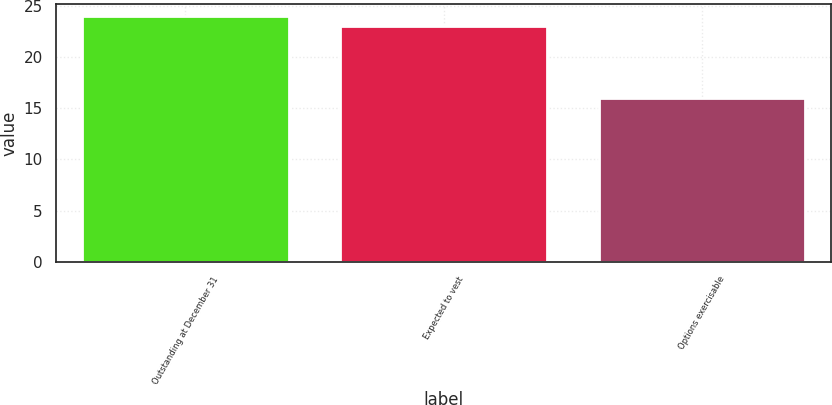Convert chart. <chart><loc_0><loc_0><loc_500><loc_500><bar_chart><fcel>Outstanding at December 31<fcel>Expected to vest<fcel>Options exercisable<nl><fcel>24<fcel>23<fcel>16<nl></chart> 